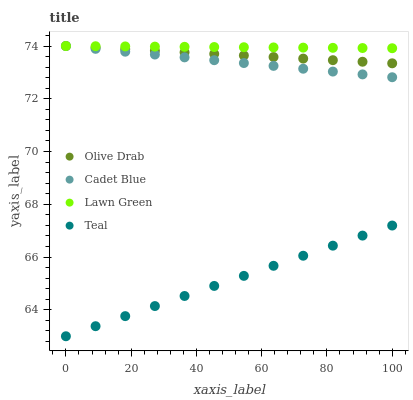Does Teal have the minimum area under the curve?
Answer yes or no. Yes. Does Lawn Green have the maximum area under the curve?
Answer yes or no. Yes. Does Cadet Blue have the minimum area under the curve?
Answer yes or no. No. Does Cadet Blue have the maximum area under the curve?
Answer yes or no. No. Is Olive Drab the smoothest?
Answer yes or no. Yes. Is Cadet Blue the roughest?
Answer yes or no. Yes. Is Teal the smoothest?
Answer yes or no. No. Is Teal the roughest?
Answer yes or no. No. Does Teal have the lowest value?
Answer yes or no. Yes. Does Cadet Blue have the lowest value?
Answer yes or no. No. Does Olive Drab have the highest value?
Answer yes or no. Yes. Does Teal have the highest value?
Answer yes or no. No. Is Teal less than Cadet Blue?
Answer yes or no. Yes. Is Cadet Blue greater than Teal?
Answer yes or no. Yes. Does Lawn Green intersect Olive Drab?
Answer yes or no. Yes. Is Lawn Green less than Olive Drab?
Answer yes or no. No. Is Lawn Green greater than Olive Drab?
Answer yes or no. No. Does Teal intersect Cadet Blue?
Answer yes or no. No. 